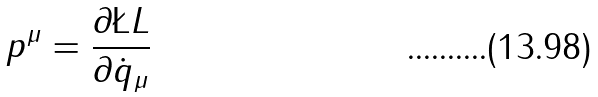Convert formula to latex. <formula><loc_0><loc_0><loc_500><loc_500>p ^ { \mu } = \frac { \partial \L L } { \partial \dot { q } _ { \mu } }</formula> 